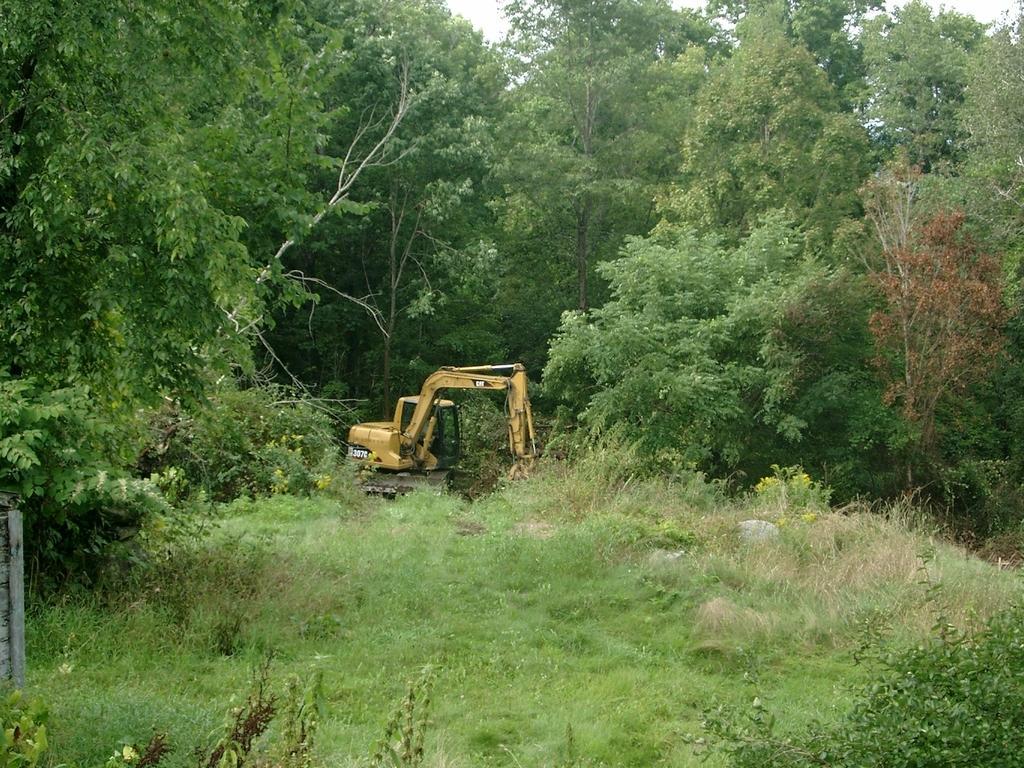Please provide a concise description of this image. In the center of the image we can see a crane. At the bottom there is grass. In the background there are trees and sky. 